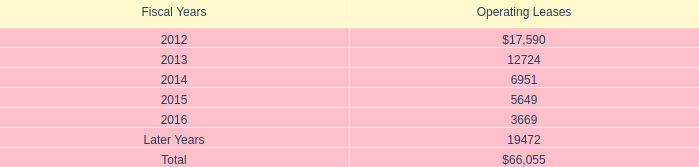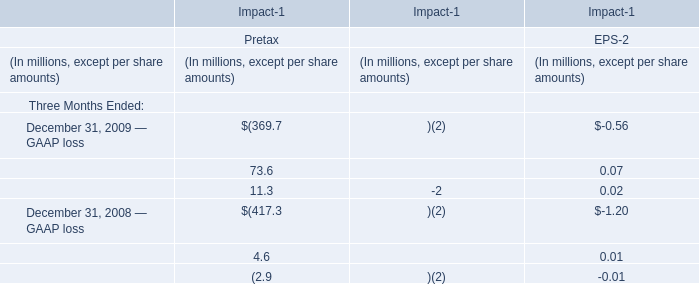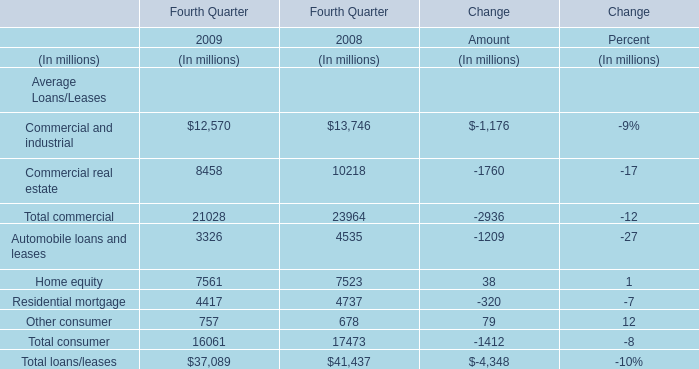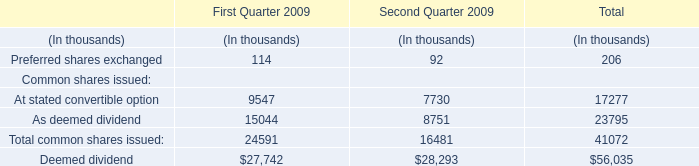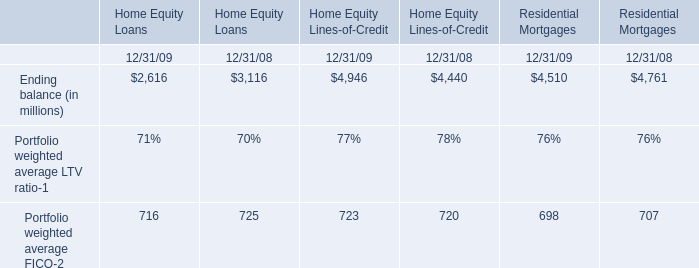Which year is Commercial real estate in Fourth Quarter lower? 
Answer: 2009. 